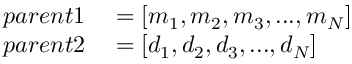<formula> <loc_0><loc_0><loc_500><loc_500>\begin{array} { r l } { p a r e n t 1 } & = [ m _ { 1 } , m _ { 2 } , m _ { 3 } , \dots , m _ { N } ] } \\ { p a r e n t 2 } & = [ d _ { 1 } , d _ { 2 } , d _ { 3 } , \dots , d _ { N } ] } \end{array}</formula> 